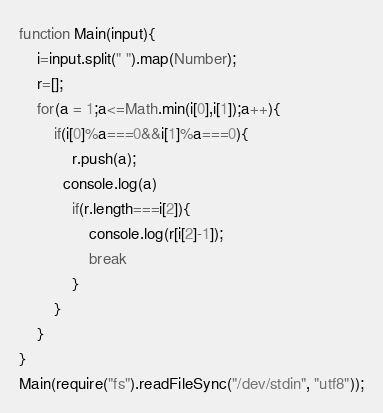Convert code to text. <code><loc_0><loc_0><loc_500><loc_500><_JavaScript_>function Main(input){
    i=input.split(" ").map(Number);
    r=[];
    for(a = 1;a<=Math.min(i[0],i[1]);a++){
        if(i[0]%a===0&&i[1]%a===0){
            r.push(a);
          console.log(a)
            if(r.length===i[2]){
                console.log(r[i[2]-1]);
                break
            }
        }
    }
}
Main(require("fs").readFileSync("/dev/stdin", "utf8"));</code> 